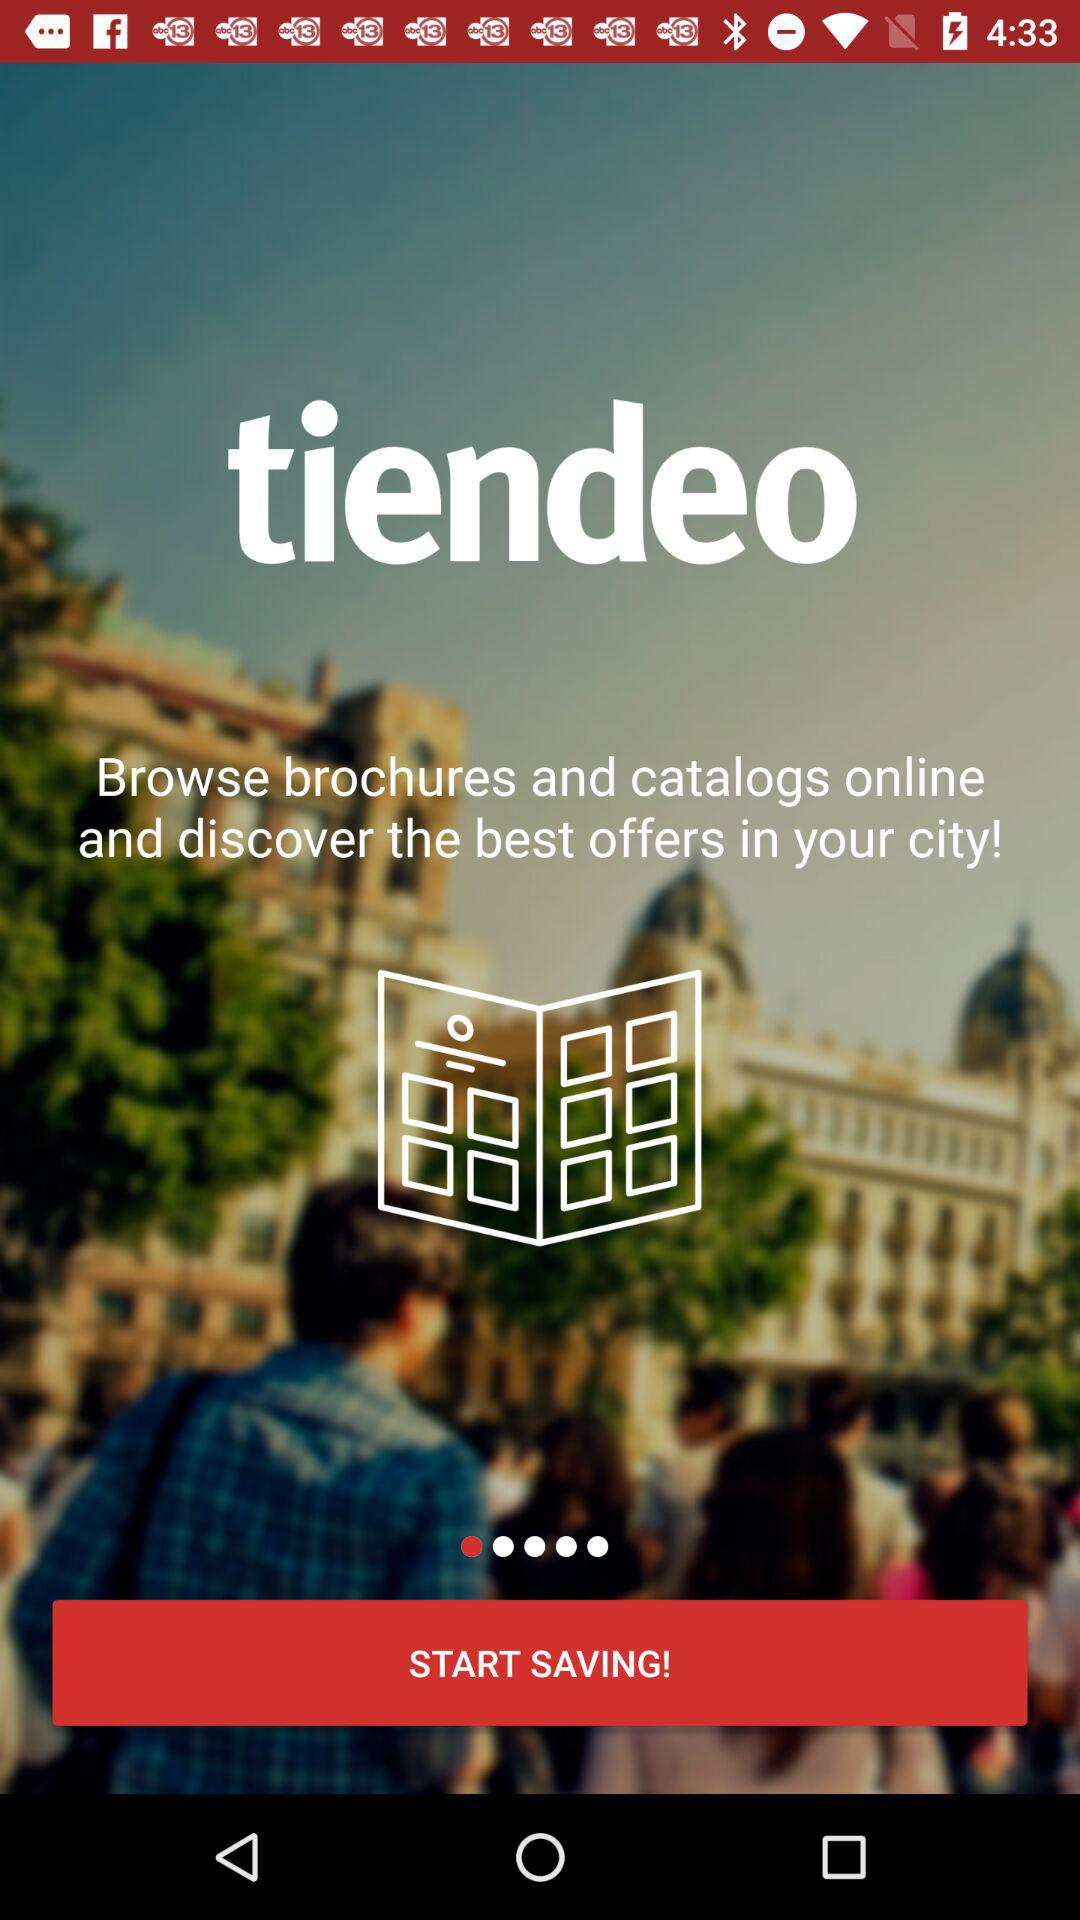What is the application name? The application name is "tiendeo". 